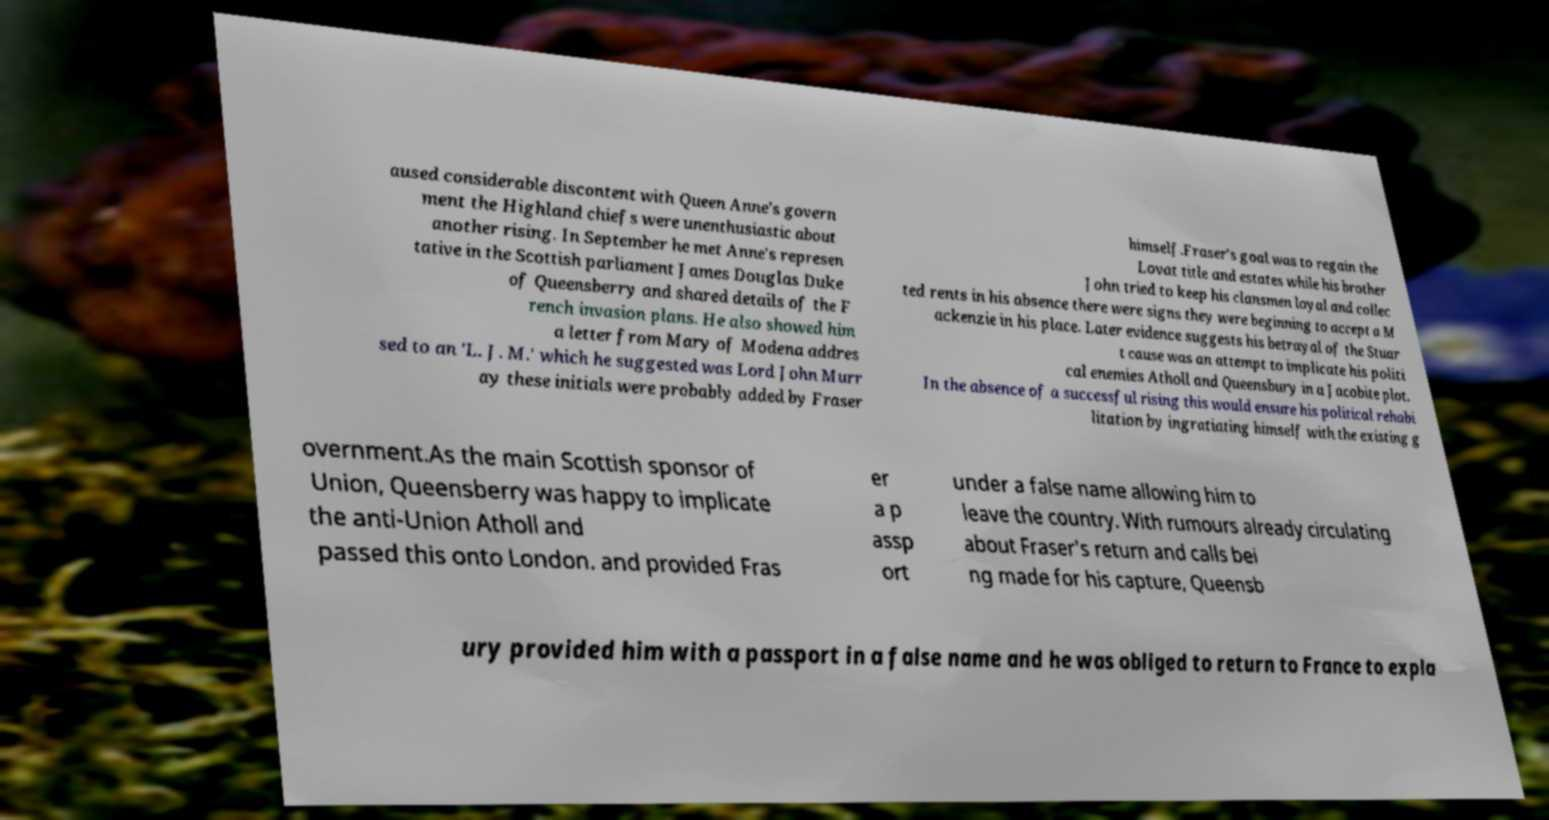What messages or text are displayed in this image? I need them in a readable, typed format. aused considerable discontent with Queen Anne's govern ment the Highland chiefs were unenthusiastic about another rising. In September he met Anne's represen tative in the Scottish parliament James Douglas Duke of Queensberry and shared details of the F rench invasion plans. He also showed him a letter from Mary of Modena addres sed to an 'L. J. M.' which he suggested was Lord John Murr ay these initials were probably added by Fraser himself.Fraser's goal was to regain the Lovat title and estates while his brother John tried to keep his clansmen loyal and collec ted rents in his absence there were signs they were beginning to accept a M ackenzie in his place. Later evidence suggests his betrayal of the Stuar t cause was an attempt to implicate his politi cal enemies Atholl and Queensbury in a Jacobite plot. In the absence of a successful rising this would ensure his political rehabi litation by ingratiating himself with the existing g overnment.As the main Scottish sponsor of Union, Queensberry was happy to implicate the anti-Union Atholl and passed this onto London. and provided Fras er a p assp ort under a false name allowing him to leave the country. With rumours already circulating about Fraser's return and calls bei ng made for his capture, Queensb ury provided him with a passport in a false name and he was obliged to return to France to expla 